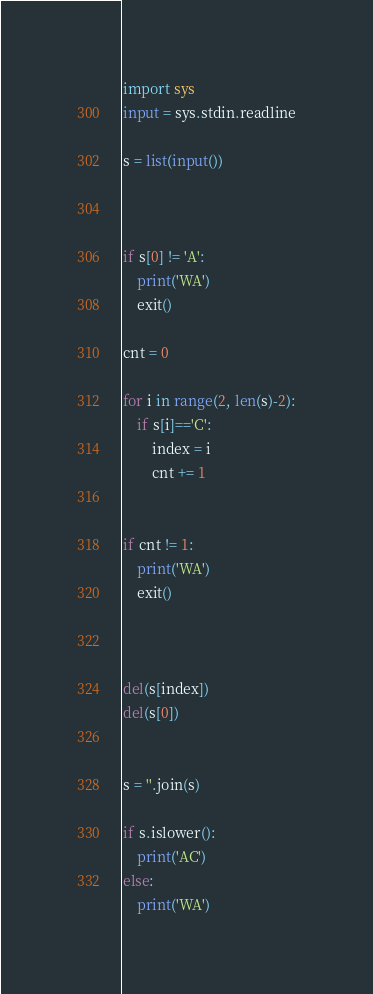Convert code to text. <code><loc_0><loc_0><loc_500><loc_500><_Python_>import sys
input = sys.stdin.readline

s = list(input())



if s[0] != 'A':
    print('WA')
    exit()

cnt = 0

for i in range(2, len(s)-2):
    if s[i]=='C':
        index = i
        cnt += 1


if cnt != 1:
    print('WA')
    exit()



del(s[index])
del(s[0])


s = ''.join(s)

if s.islower():
    print('AC')
else:
    print('WA')</code> 